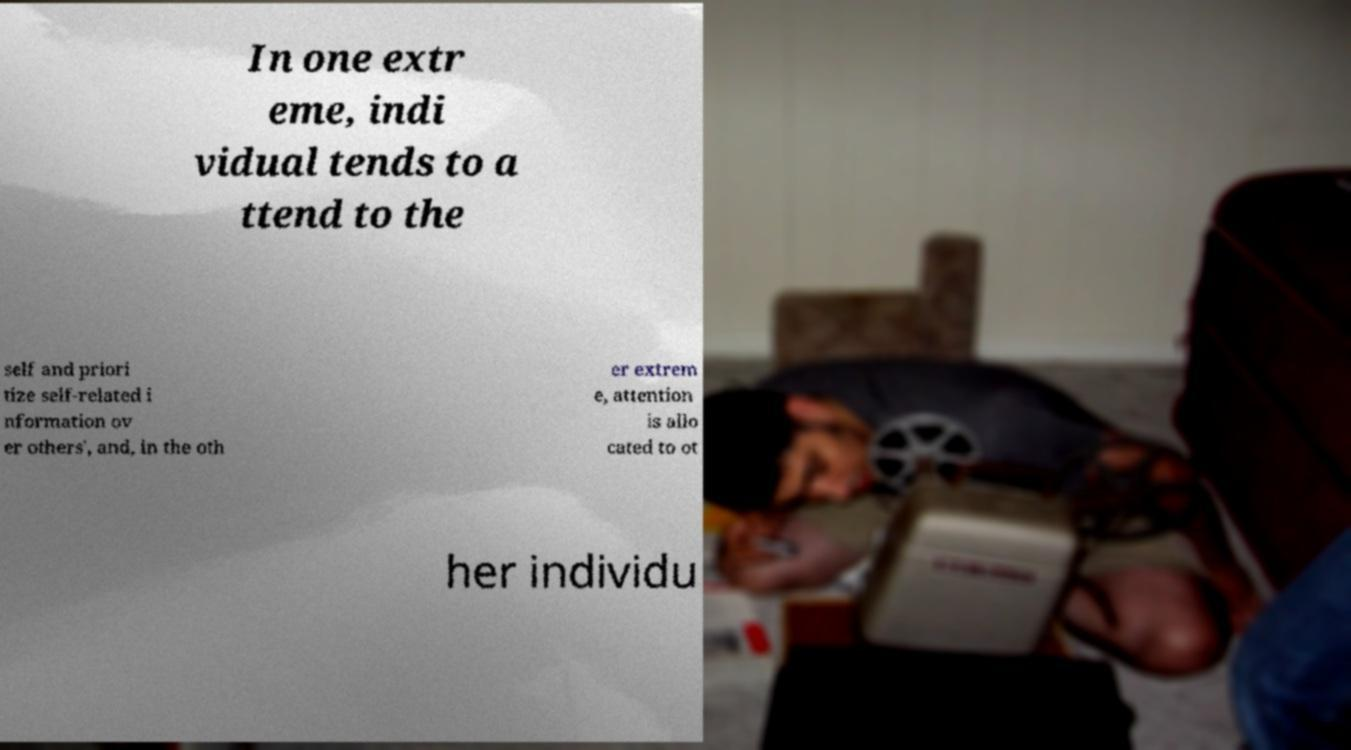Please identify and transcribe the text found in this image. In one extr eme, indi vidual tends to a ttend to the self and priori tize self-related i nformation ov er others', and, in the oth er extrem e, attention is allo cated to ot her individu 